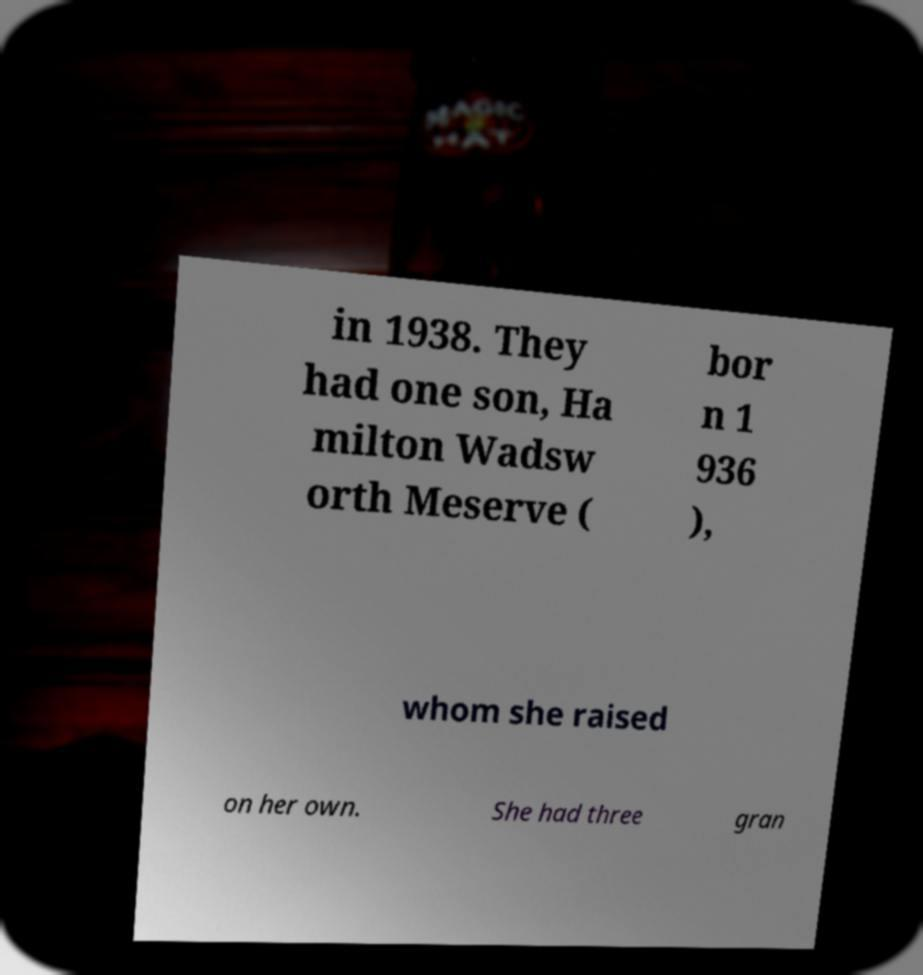There's text embedded in this image that I need extracted. Can you transcribe it verbatim? in 1938. They had one son, Ha milton Wadsw orth Meserve ( bor n 1 936 ), whom she raised on her own. She had three gran 